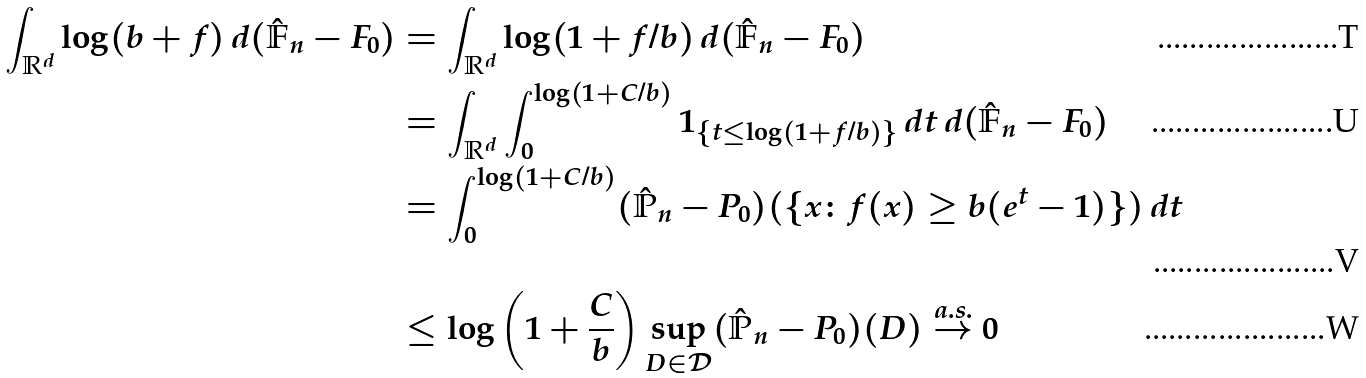<formula> <loc_0><loc_0><loc_500><loc_500>\int _ { \mathbb { R } ^ { d } } \log ( b + f ) \, d ( \hat { \mathbb { F } } _ { n } - F _ { 0 } ) & = \int _ { \mathbb { R } ^ { d } } \log ( 1 + f / b ) \, d ( \hat { \mathbb { F } } _ { n } - F _ { 0 } ) \\ & = \int _ { \mathbb { R } ^ { d } } \int _ { 0 } ^ { \log ( 1 + C / b ) } \mathbb { m } { 1 } _ { \{ t \leq \log ( 1 + f / b ) \} } \, d t \, d ( \hat { \mathbb { F } } _ { n } - F _ { 0 } ) \\ & = \int _ { 0 } ^ { \log ( 1 + C / b ) } ( \hat { \mathbb { P } } _ { n } - P _ { 0 } ) ( \{ x \colon f ( x ) \geq b ( e ^ { t } - 1 ) \} ) \, d t \\ & \leq \log \left ( 1 + \frac { C } { b } \right ) \sup _ { D \in \mathcal { D } } ( \hat { \mathbb { P } } _ { n } - P _ { 0 } ) ( D ) \stackrel { a . s . } { \rightarrow } 0</formula> 